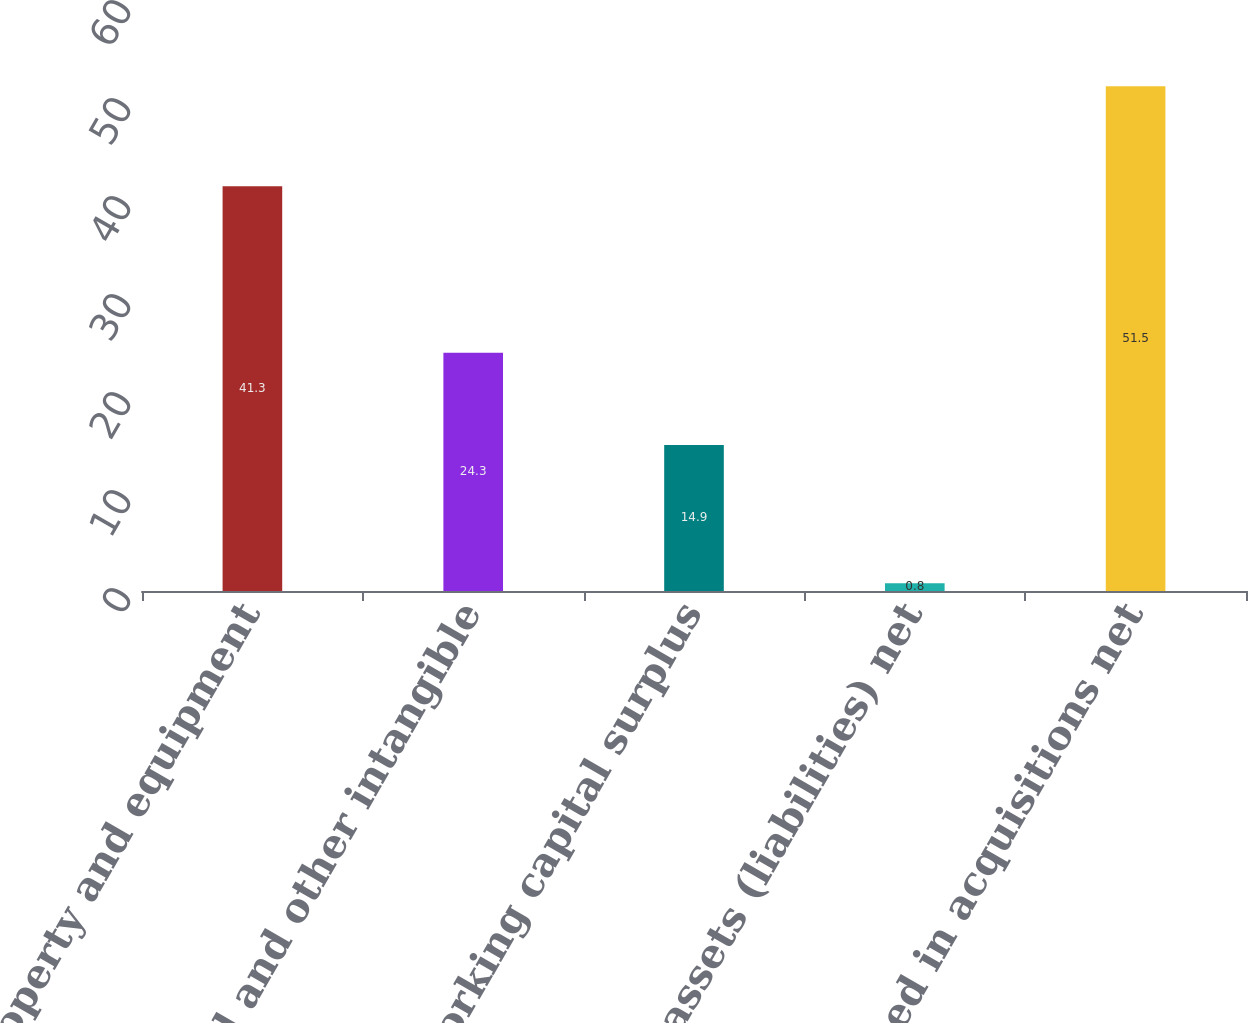<chart> <loc_0><loc_0><loc_500><loc_500><bar_chart><fcel>Property and equipment<fcel>Goodwill and other intangible<fcel>Working capital surplus<fcel>Other assets (liabilities) net<fcel>Cash used in acquisitions net<nl><fcel>41.3<fcel>24.3<fcel>14.9<fcel>0.8<fcel>51.5<nl></chart> 